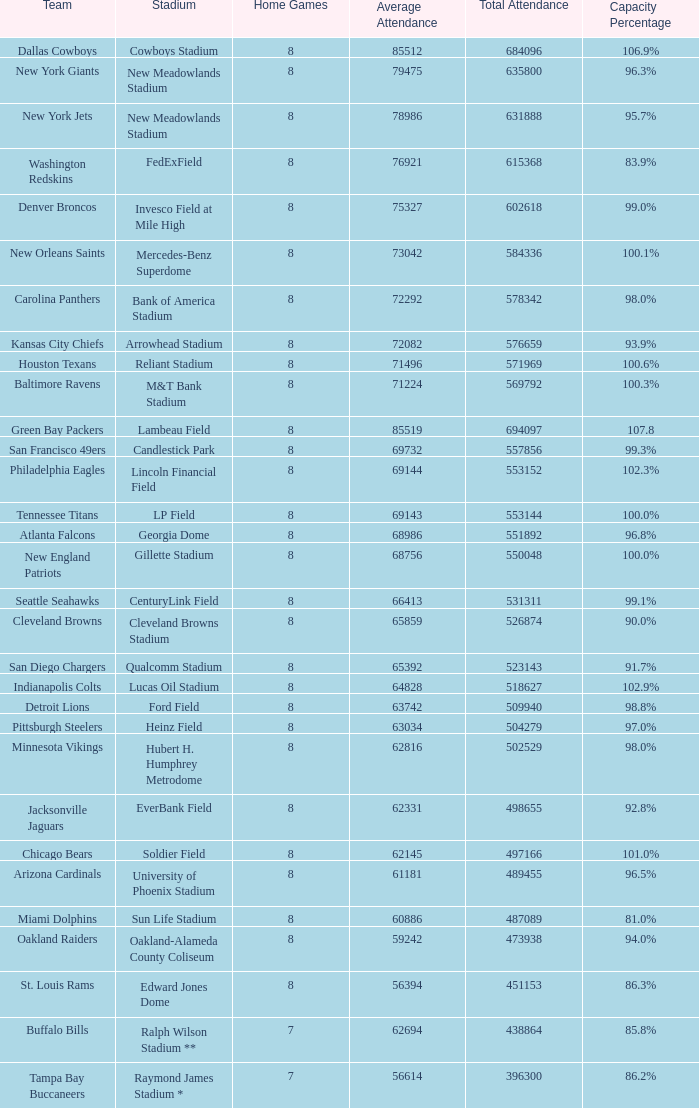When the stadium mentioned is edward jones dome, which team's name corresponds to it? St. Louis Rams. 